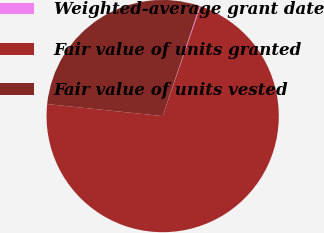Convert chart. <chart><loc_0><loc_0><loc_500><loc_500><pie_chart><fcel>Weighted-average grant date<fcel>Fair value of units granted<fcel>Fair value of units vested<nl><fcel>0.13%<fcel>71.35%<fcel>28.52%<nl></chart> 